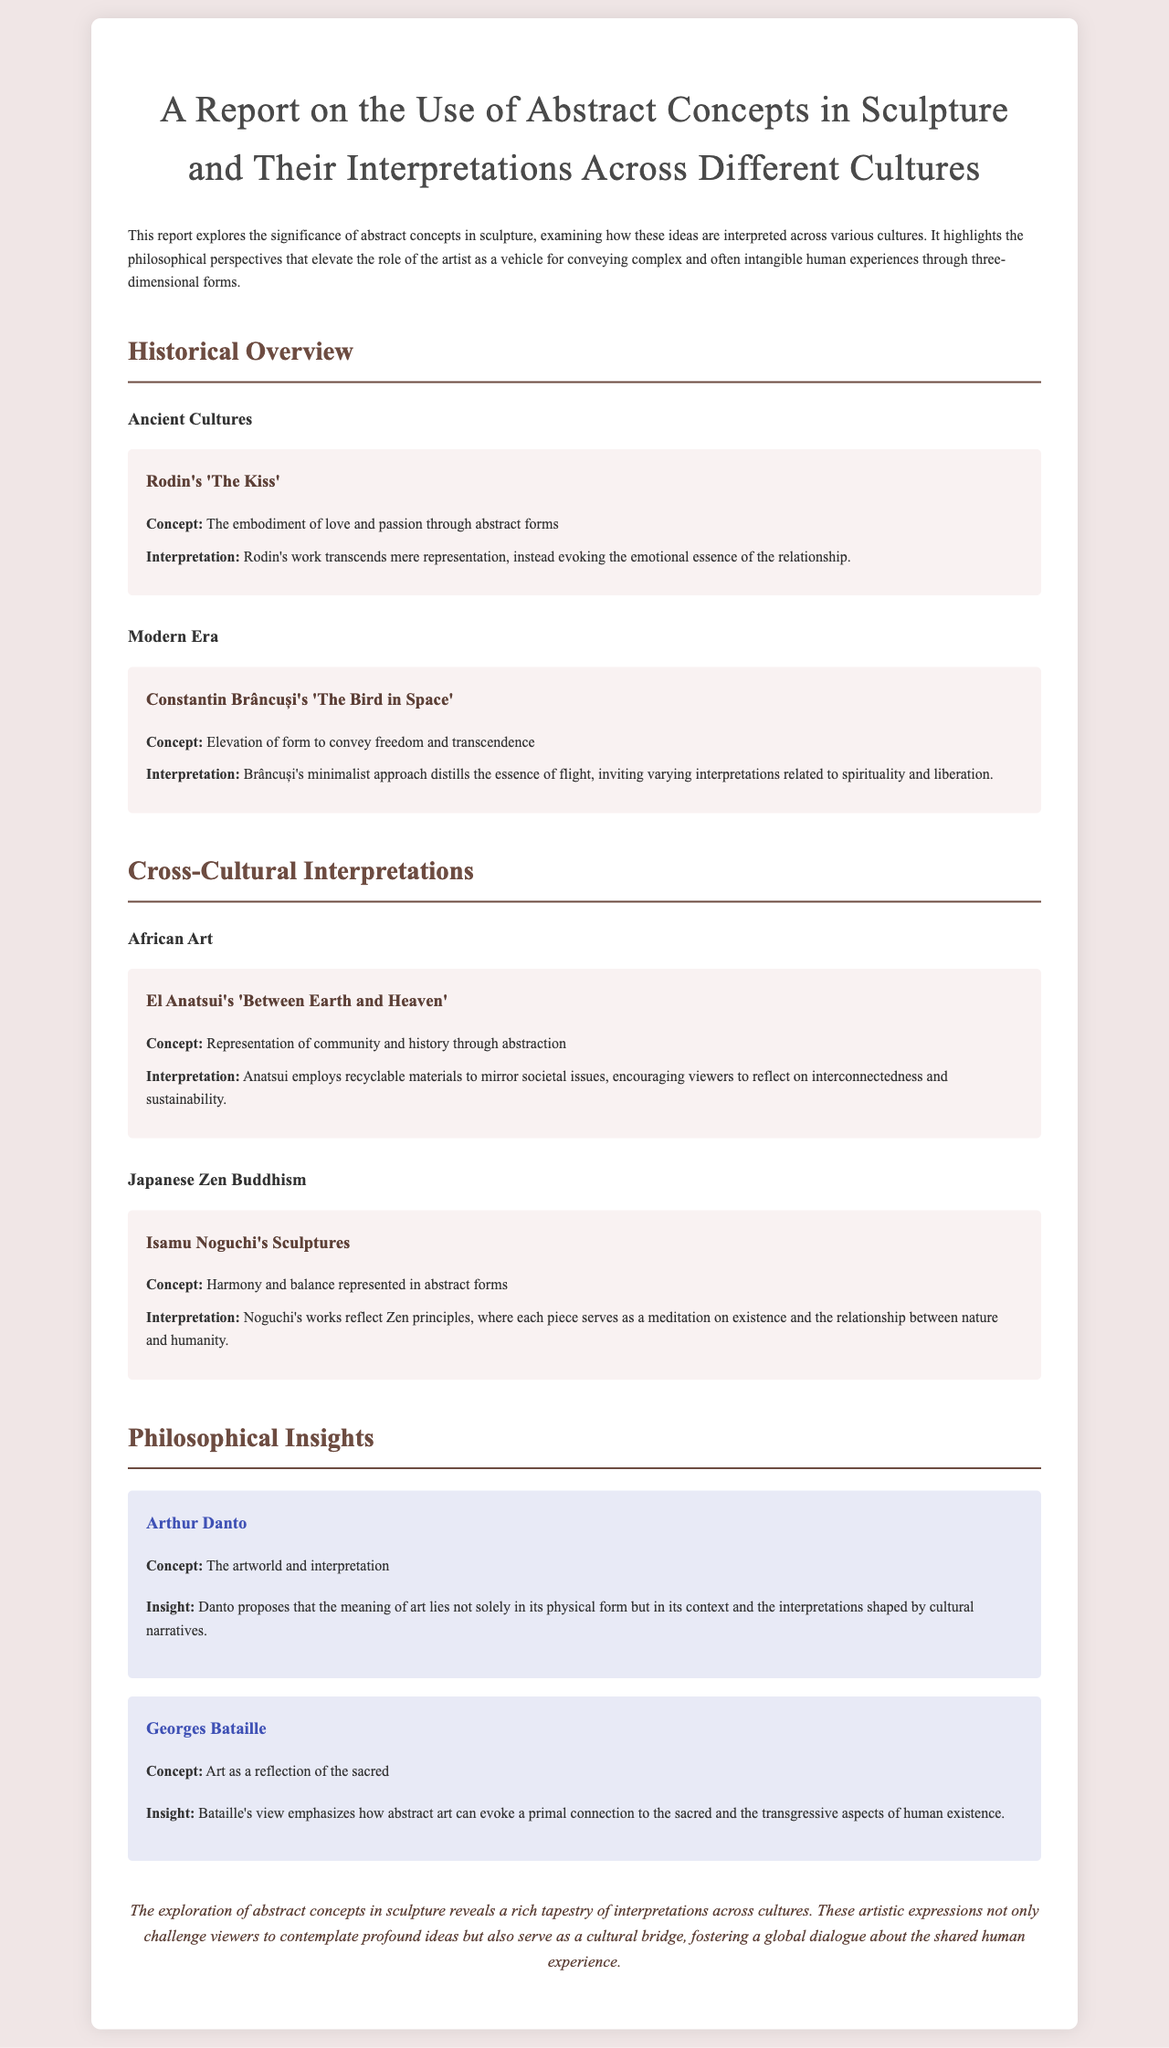What is the title of the report? The title is provided at the beginning of the document, which outlines the content of the report.
Answer: A Report on the Use of Abstract Concepts in Sculpture and Their Interpretations Across Different Cultures Who created 'The Bird in Space'? This information is found in the section discussing modern sculpture.
Answer: Constantin Brâncuși What does El Anatsui's 'Between Earth and Heaven' represent? The report provides a description of the concept represented in this specific artwork.
Answer: Community and history Which philosophical insight emphasizes the context of art? This insight is attributed to a specific philosopher mentioned in the report.
Answer: Arthur Danto What does Isamu Noguchi's work reflect? The report provides insight into the themes present in Noguchi's sculptures.
Answer: Zen principles How does Chau's work encourage viewers? The report specifies how Anatsui's work interacts with societal issues and viewer thought.
Answer: Reflect on interconnectedness and sustainability 